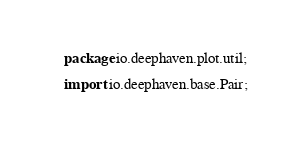Convert code to text. <code><loc_0><loc_0><loc_500><loc_500><_Java_>package io.deephaven.plot.util;

import io.deephaven.base.Pair;</code> 